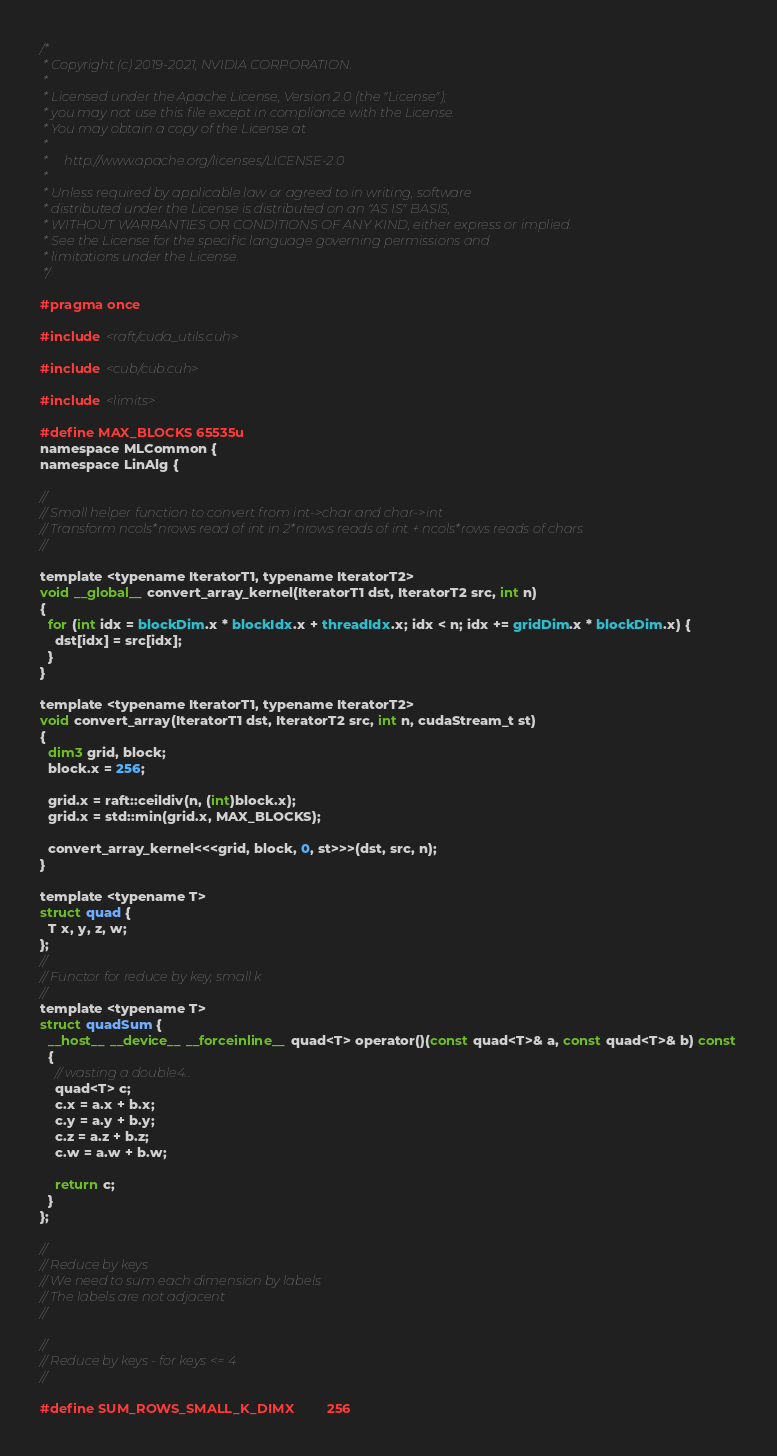Convert code to text. <code><loc_0><loc_0><loc_500><loc_500><_Cuda_>/*
 * Copyright (c) 2019-2021, NVIDIA CORPORATION.
 *
 * Licensed under the Apache License, Version 2.0 (the "License");
 * you may not use this file except in compliance with the License.
 * You may obtain a copy of the License at
 *
 *     http://www.apache.org/licenses/LICENSE-2.0
 *
 * Unless required by applicable law or agreed to in writing, software
 * distributed under the License is distributed on an "AS IS" BASIS,
 * WITHOUT WARRANTIES OR CONDITIONS OF ANY KIND, either express or implied.
 * See the License for the specific language governing permissions and
 * limitations under the License.
 */

#pragma once

#include <raft/cuda_utils.cuh>

#include <cub/cub.cuh>

#include <limits>

#define MAX_BLOCKS 65535u
namespace MLCommon {
namespace LinAlg {

//
// Small helper function to convert from int->char and char->int
// Transform ncols*nrows read of int in 2*nrows reads of int + ncols*rows reads of chars
//

template <typename IteratorT1, typename IteratorT2>
void __global__ convert_array_kernel(IteratorT1 dst, IteratorT2 src, int n)
{
  for (int idx = blockDim.x * blockIdx.x + threadIdx.x; idx < n; idx += gridDim.x * blockDim.x) {
    dst[idx] = src[idx];
  }
}

template <typename IteratorT1, typename IteratorT2>
void convert_array(IteratorT1 dst, IteratorT2 src, int n, cudaStream_t st)
{
  dim3 grid, block;
  block.x = 256;

  grid.x = raft::ceildiv(n, (int)block.x);
  grid.x = std::min(grid.x, MAX_BLOCKS);

  convert_array_kernel<<<grid, block, 0, st>>>(dst, src, n);
}

template <typename T>
struct quad {
  T x, y, z, w;
};
//
// Functor for reduce by key, small k
//
template <typename T>
struct quadSum {
  __host__ __device__ __forceinline__ quad<T> operator()(const quad<T>& a, const quad<T>& b) const
  {
    // wasting a double4..
    quad<T> c;
    c.x = a.x + b.x;
    c.y = a.y + b.y;
    c.z = a.z + b.z;
    c.w = a.w + b.w;

    return c;
  }
};

//
// Reduce by keys
// We need to sum each dimension by labels
// The labels are not adjacent
//

//
// Reduce by keys - for keys <= 4
//

#define SUM_ROWS_SMALL_K_DIMX         256</code> 